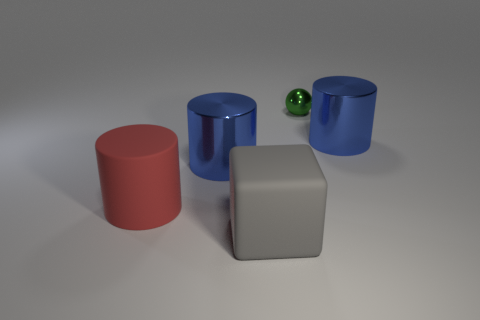Add 1 matte objects. How many objects exist? 6 Subtract all blue cylinders. How many cylinders are left? 1 Subtract all red cylinders. How many cylinders are left? 2 Subtract all cylinders. How many objects are left? 2 Subtract 1 cubes. How many cubes are left? 0 Subtract all purple balls. How many blue cylinders are left? 2 Subtract all small green shiny balls. Subtract all large rubber cubes. How many objects are left? 3 Add 3 blue metallic cylinders. How many blue metallic cylinders are left? 5 Add 3 big yellow shiny spheres. How many big yellow shiny spheres exist? 3 Subtract 0 green cylinders. How many objects are left? 5 